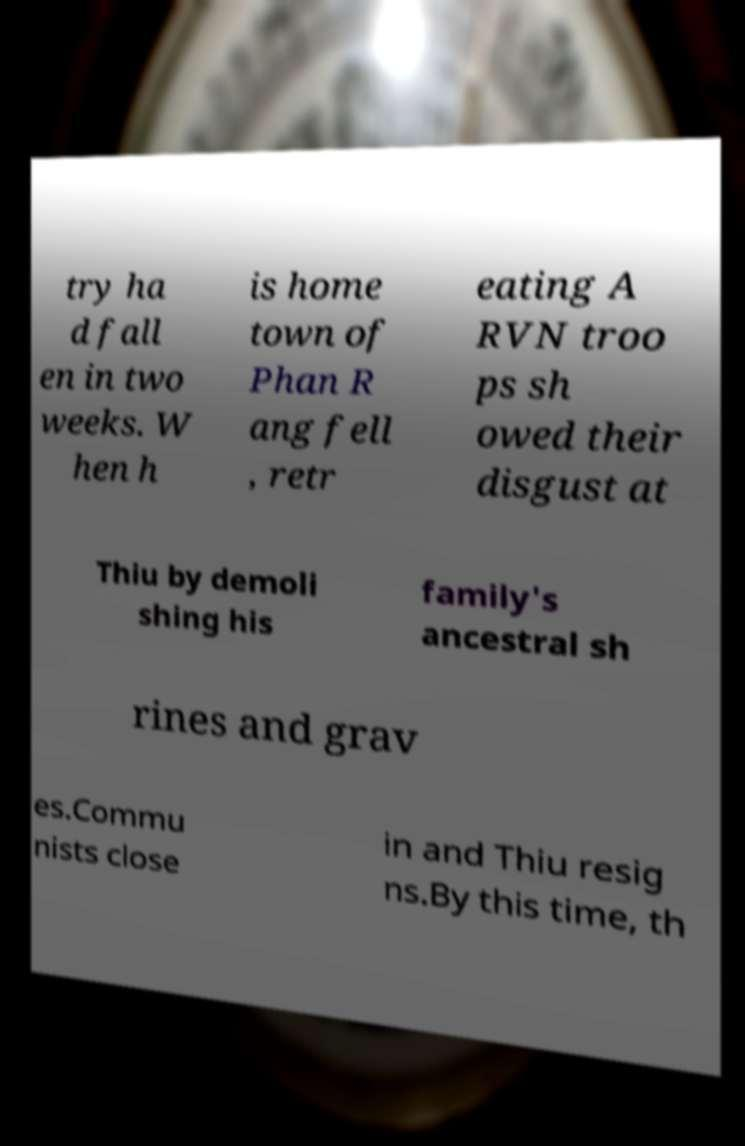What messages or text are displayed in this image? I need them in a readable, typed format. try ha d fall en in two weeks. W hen h is home town of Phan R ang fell , retr eating A RVN troo ps sh owed their disgust at Thiu by demoli shing his family's ancestral sh rines and grav es.Commu nists close in and Thiu resig ns.By this time, th 